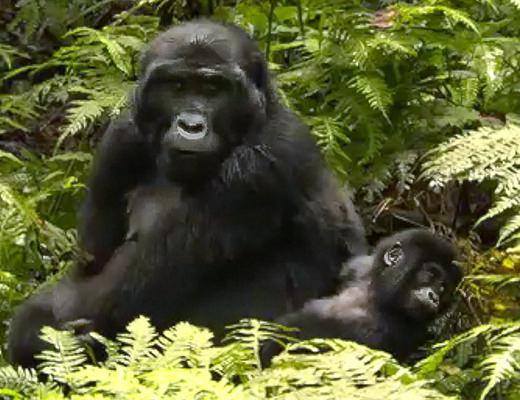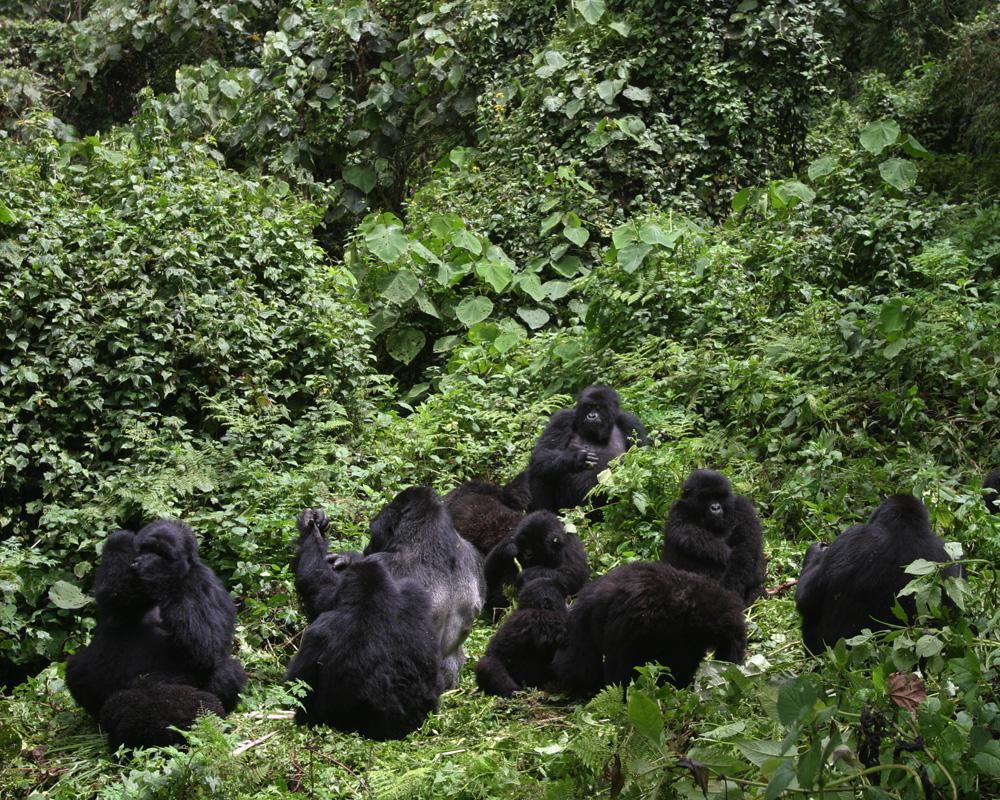The first image is the image on the left, the second image is the image on the right. For the images shown, is this caption "One image contains at least eight apes." true? Answer yes or no. Yes. The first image is the image on the left, the second image is the image on the right. Analyze the images presented: Is the assertion "A group of four or more gorillas is assembled in the forest." valid? Answer yes or no. Yes. 